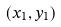Convert formula to latex. <formula><loc_0><loc_0><loc_500><loc_500>( x _ { 1 } , y _ { 1 } )</formula> 